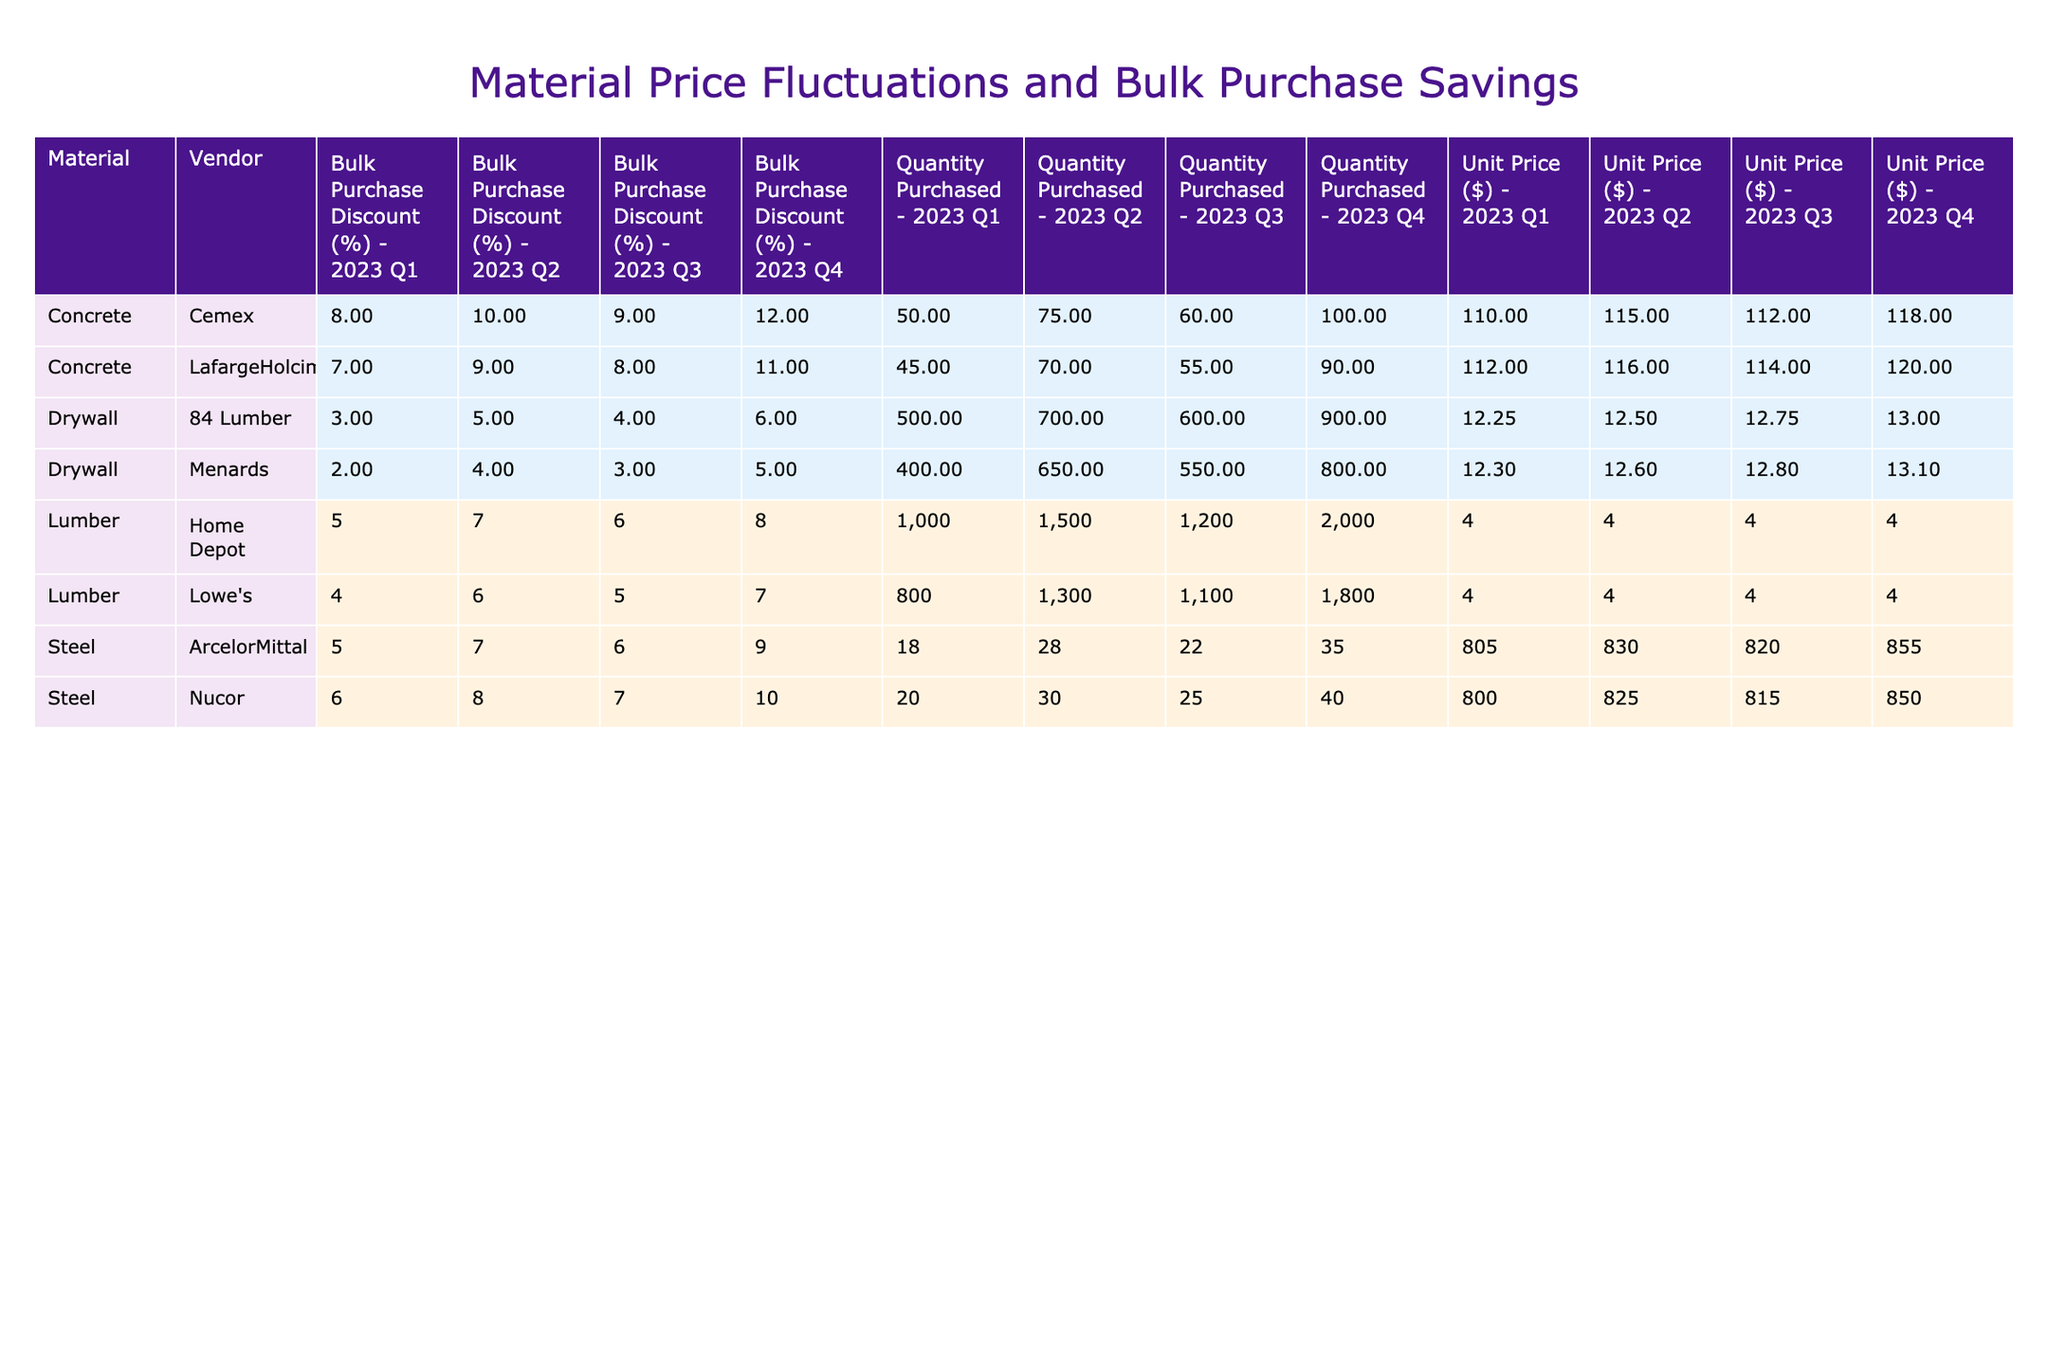What was the highest unit price for lumber offered by Home Depot in 2023? Looking at the table, the unit prices for lumber from Home Depot in 2023 are: Q1: 3.50, Q2: 3.75, Q3: 3.60, Q4: 3.80. The highest value among these is 3.80 in Q4.
Answer: 3.80 What vendor provided the lowest bulk purchase discount for drywall in Q2 2023? The bulk purchase discounts for drywall in Q2 2023 are: 84 Lumber: 5% and Menards: 4%. The lower value is the one from Menards.
Answer: Menards What is the total quantity of concrete purchased from Cemex in 2023? The quantities purchased from Cemex by quarter in 2023 are: Q1: 50, Q2: 75, Q3: 60, Q4: 100. Adding these gives 50 + 75 + 60 + 100 = 285.
Answer: 285 Which vendor had the highest unit price for steel in Q3 2023? In Q3 2023, the unit prices for steel are: Nucor: 815.00 and ArcelorMittal: 820.00. The highest unit price is from ArcelorMittal.
Answer: ArcelorMittal Was there a year where the bulk purchase discount for lumber from Lowe's exceeded 7%? The bulk purchase discounts for Lowe's lumber in 2023 are: Q1: 4%, Q2: 6%, Q3: 5%, Q4: 7%. None of these exceed 7%.
Answer: No Which quarter had the highest average bulk purchase discount for concrete across both vendors? The discounts for concrete are: Cemex (Q1: 8%, Q2: 10%, Q3: 9%, Q4: 12%) and LafargeHolcim (Q1: 7%, Q2: 9%, Q3: 8%, Q4: 11%). The averages per quarter are: Q1: 7.5%, Q2: 9.5%, Q3: 8.5%, Q4: 11.5%. The highest is Q4 at 11.5%.
Answer: Q4 What is the trend of unit price increases for lumber from Home Depot throughout 2023? The unit prices for Home Depot lumber by quarter are: Q1: 3.50, Q2: 3.75, Q3: 3.60, Q4: 3.80. The prices generally increased from Q1 to Q2, decreased slightly to Q3, and then increased again in Q4, indicating slight fluctuations.
Answer: Fluctuations How many more units of drywall were purchased from 84 Lumber compared to Menards in Q1 2023? The quantities for Q1 are 84 Lumber: 500 and Menards: 400. Finding the difference gives 500 - 400 = 100.
Answer: 100 